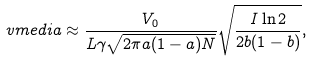Convert formula to latex. <formula><loc_0><loc_0><loc_500><loc_500>\ v m e d i a \approx \frac { V _ { 0 } } { L \gamma \sqrt { 2 \pi a ( 1 - a ) N } } \sqrt { \frac { I \ln 2 } { 2 b ( 1 - b ) } } ,</formula> 